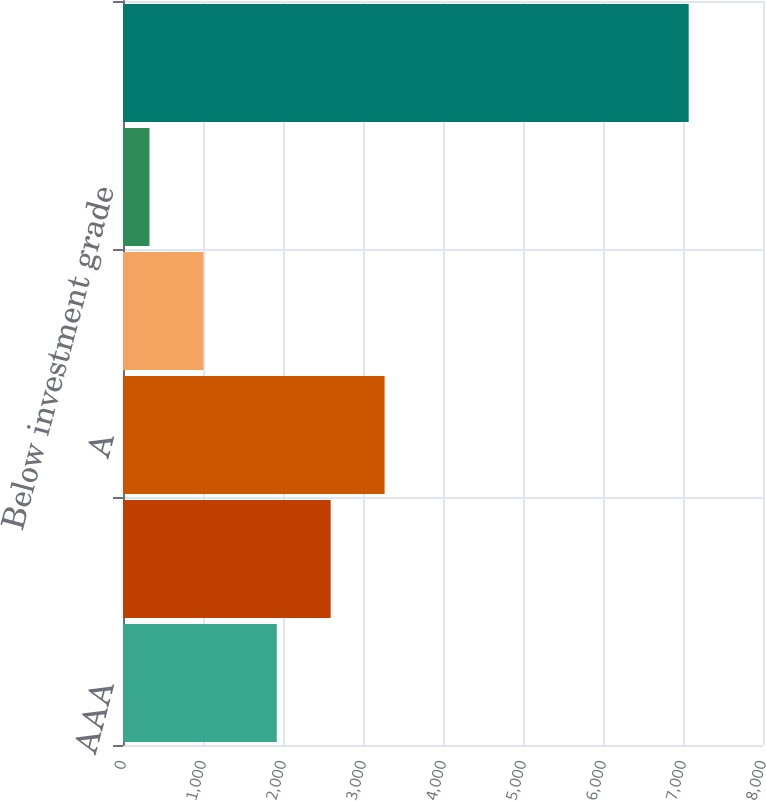<chart> <loc_0><loc_0><loc_500><loc_500><bar_chart><fcel>AAA<fcel>AA<fcel>A<fcel>BBB<fcel>Below investment grade<fcel>Total<nl><fcel>1922<fcel>2596<fcel>3270<fcel>1005<fcel>331<fcel>7071<nl></chart> 